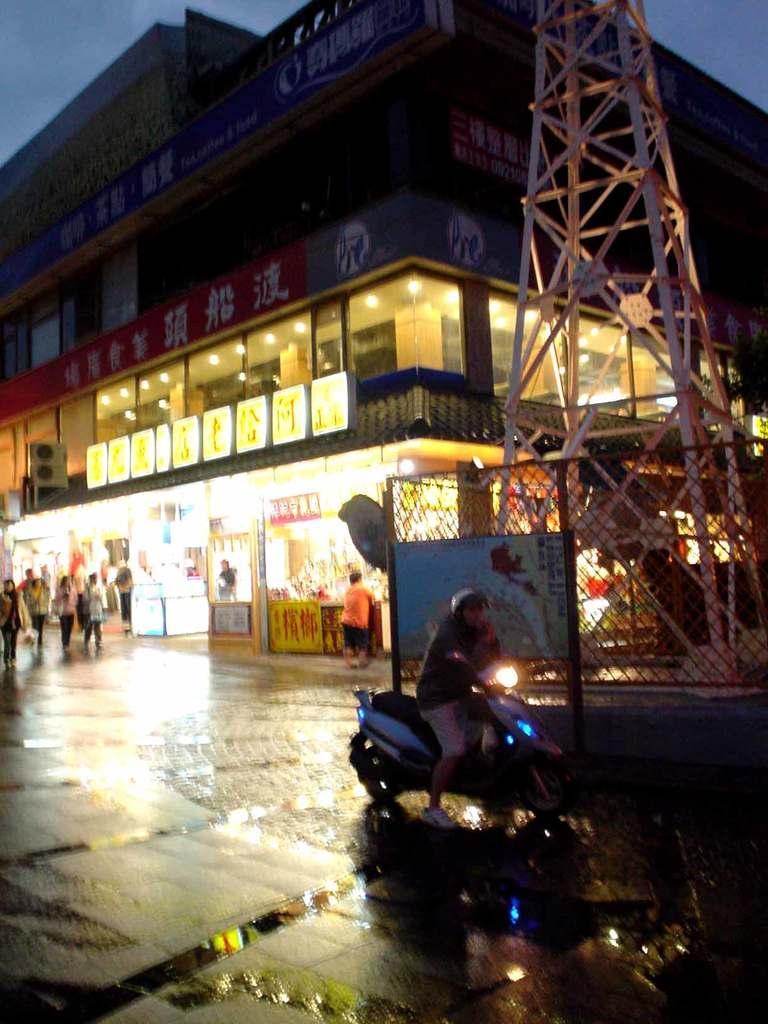Please provide a concise description of this image. This image consists of a person riding a vehicle. At the bottom, there is a road. In the background, we can see a building along with the shops. On the right, there is a tower. On the left, there are many people on the road. At the top, there is the sky. 